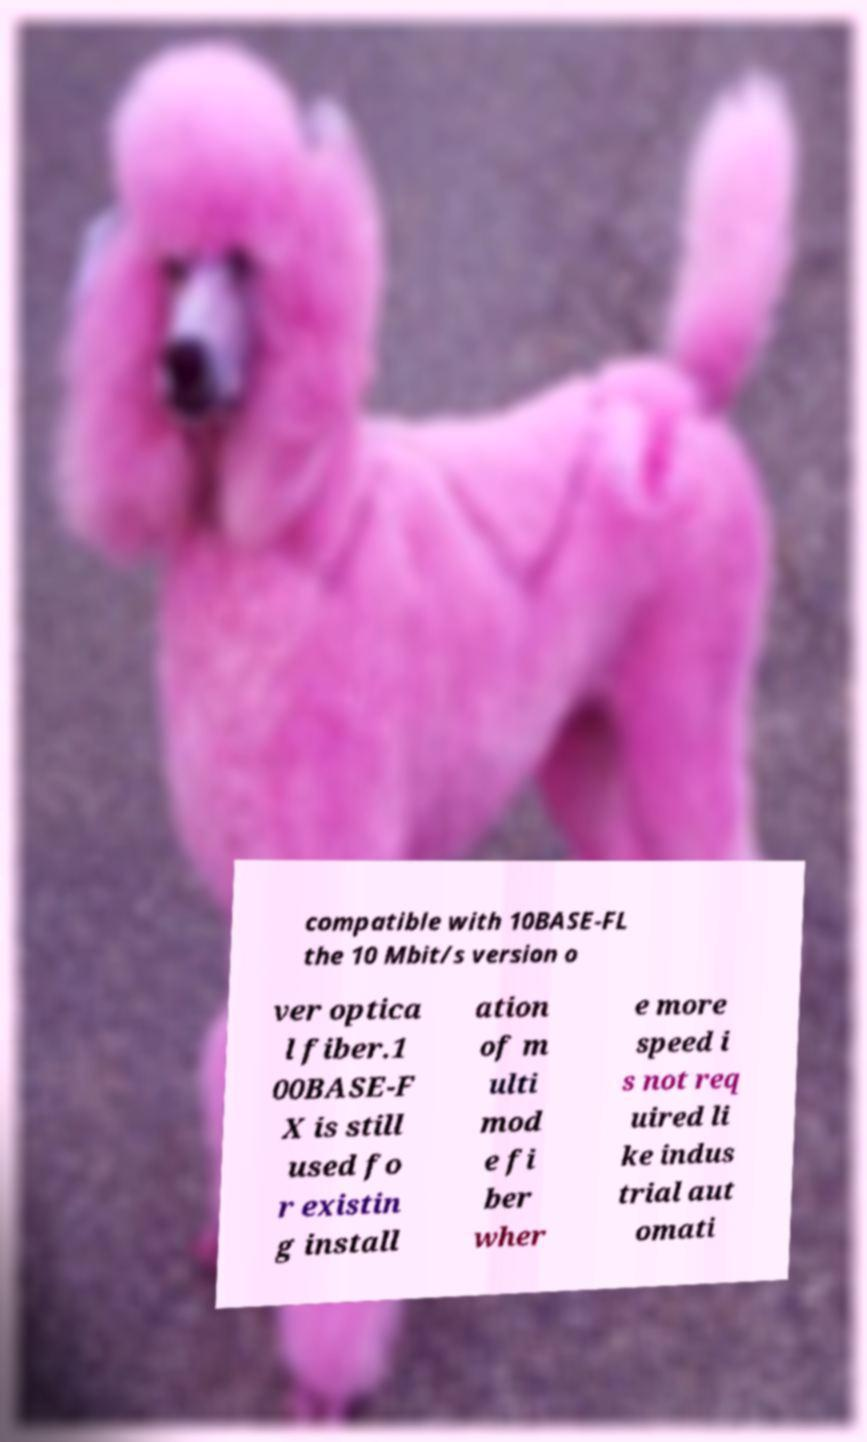I need the written content from this picture converted into text. Can you do that? compatible with 10BASE-FL the 10 Mbit/s version o ver optica l fiber.1 00BASE-F X is still used fo r existin g install ation of m ulti mod e fi ber wher e more speed i s not req uired li ke indus trial aut omati 